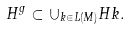<formula> <loc_0><loc_0><loc_500><loc_500>H ^ { g } \subset \cup _ { k \in L ( M ) } H k .</formula> 